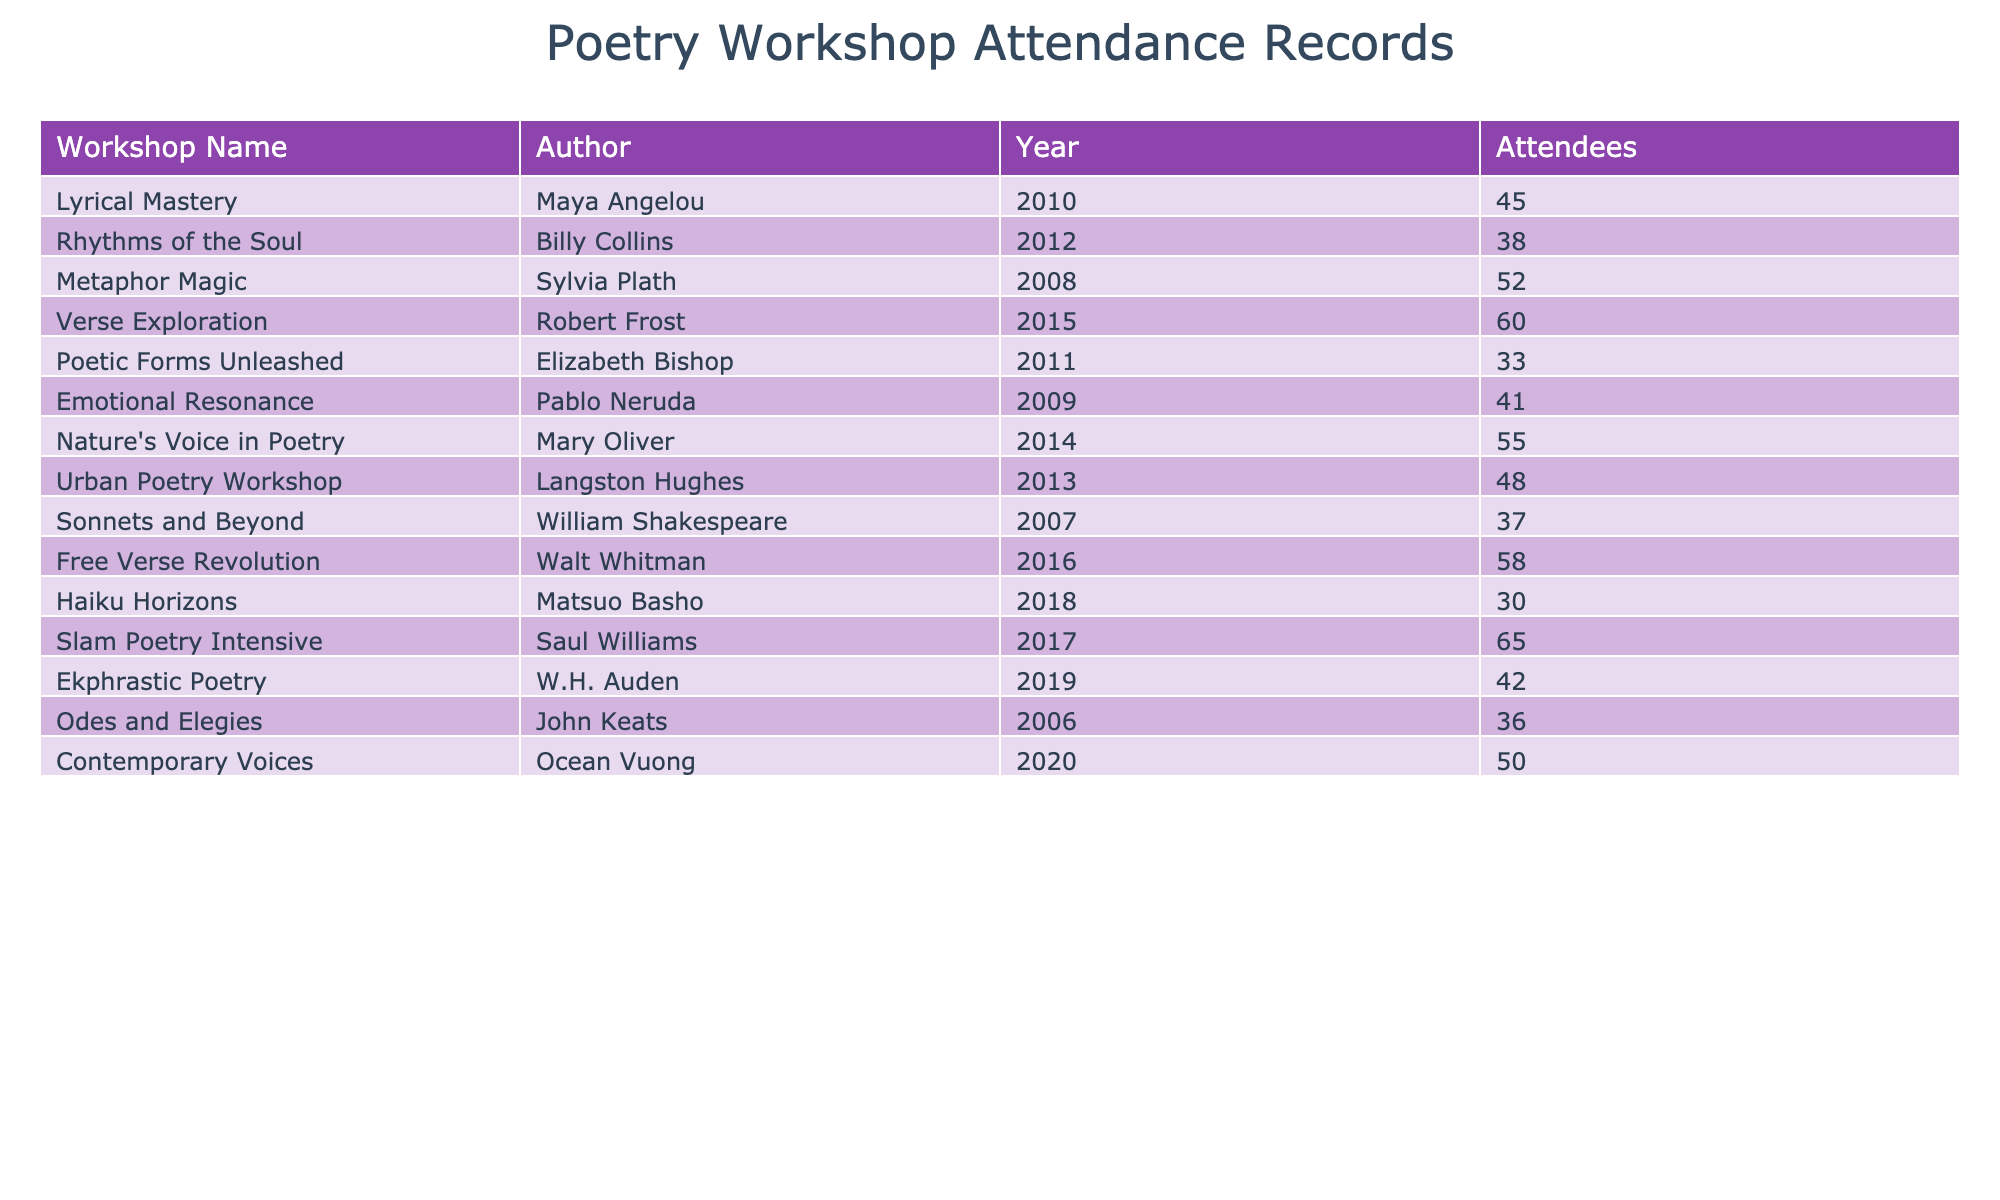What was the attendance at the Slam Poetry Intensive workshop? Looking at the table, the attendance for the Slam Poetry Intensive workshop is listed directly next to it. The table shows that 65 attendees took part in this workshop.
Answer: 65 Which author had the least number of attendees at their workshop? By scanning through the attendance records in the table, I can see that the minimum attendance is found next to the Haiku Horizons workshop, which shows only 30 attendees.
Answer: 30 How many workshops had over 50 attendees? Counting the workshops with attendance greater than 50 from the table, these are Verse Exploration (60), Nature's Voice in Poetry (55), Free Verse Revolution (58), and Slam Poetry Intensive (65). That totals four workshops.
Answer: 4 What is the average attendance across all workshops? To find the average attendance, I need to sum the total number of attendees (45 + 38 + 52 + 60 + 33 + 41 + 55 + 48 + 37 + 58 + 30 + 65 + 42 + 36 + 50 = 680) and divide by the number of workshops (15). The average is 680/15 = 45.33.
Answer: 45.33 Did any workshop led by a female author have more than 60 attendees? In the female author's workshops listed in the table, Maya Angelou, Sylvia Plath, Elizabeth Bishop, and Mary Oliver had 45, 52, 33, and 55 attendees, respectively. Only the Slam Poetry Intensive, led by Saul Williams, which is not female, had 65 attendees. Therefore, the answer is no.
Answer: No Which workshop had the highest attendance? Referring to the table, the workshop with the highest attendance is the Slam Poetry Intensive with 65 attendees.
Answer: 65 What is the difference in attendance between the workshop with the highest and the lowest attendance? From the previous findings, the highest attendance is 65 (Slam Poetry Intensive) and the lowest is 30 (Haiku Horizons). The difference is 65 - 30 = 35.
Answer: 35 Is there any workshop in the year 2014? Checking the table, I find Nature's Voice in Poetry listed for the year 2014. Therefore, there is a workshop in that year.
Answer: Yes Which two authors had workshops in 2012 and 2013, and what were their attendance figures? In 2012, the author is Billy Collins with 38 attendees. In 2013, Langston Hughes led the workshop with 48 attendees.
Answer: Billy Collins: 38, Langston Hughes: 48 What percentage of the total attendees were present in the Emotional Resonance workshop? The Emotional Resonance workshop had 41 attendees. The total attendance is 680. Therefore, the percentage is (41/680) * 100 = 6.04%.
Answer: 6.04% 